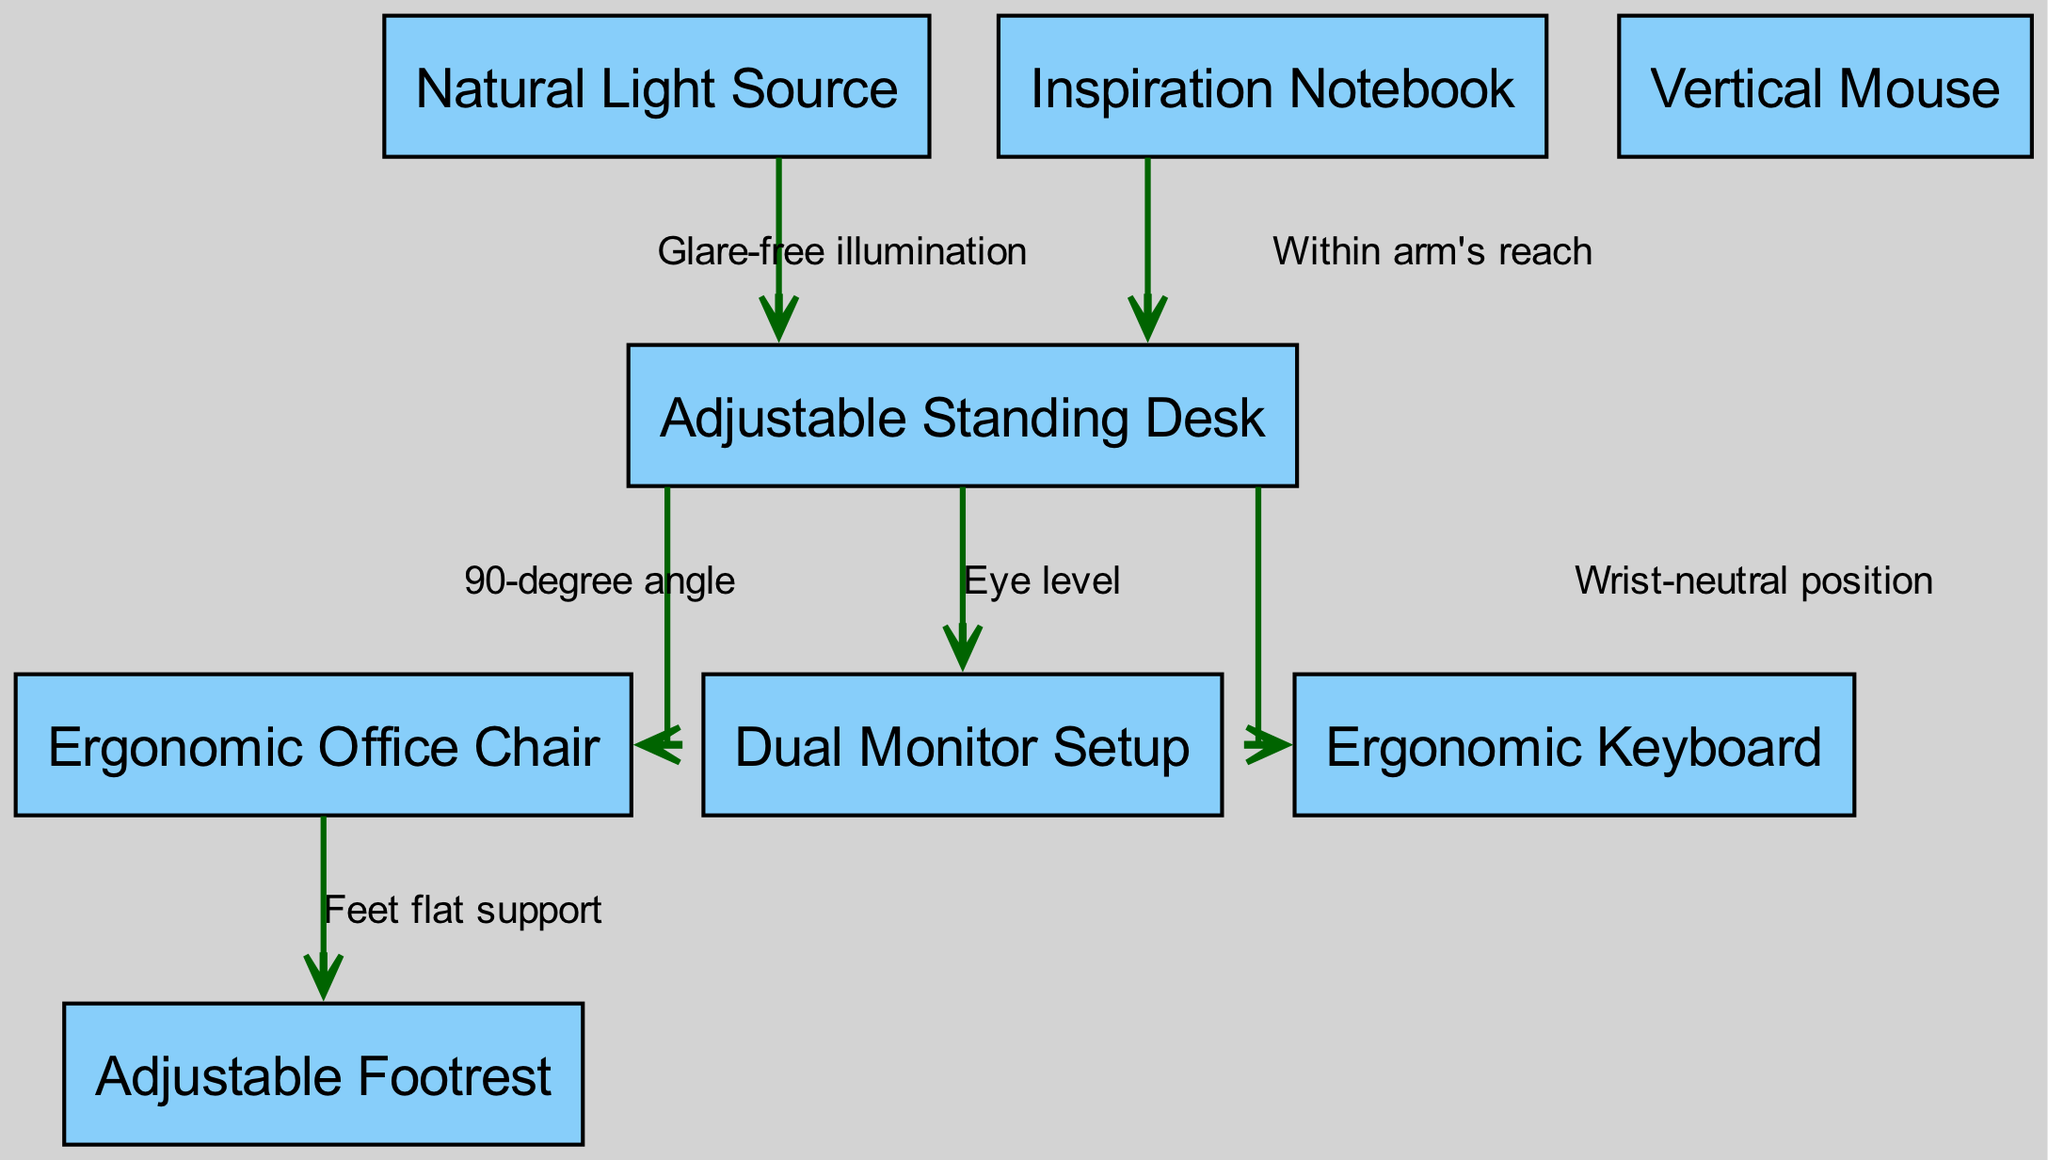What is the label of the first node? The first node in the diagram is labeled "Adjustable Standing Desk." This can be directly observed by looking at the nodes listed in the diagram.
Answer: Adjustable Standing Desk How many nodes are there in total? The diagram lists eight different components that make up the ergonomic workspace, which are labeled as nodes. Counting these nodes gives a total of eight.
Answer: Eight What is the relationship between the desk and the monitor? The diagram indicates that the desk is positioned in a way that keeps the monitor at eye level. This is specified in the edge connecting these two nodes.
Answer: Eye level What supports the feet in the chair setup? The edge connecting the chair and the footrest indicates that the footrest provides flat support for the feet while seated in the chair.
Answer: Feet flat support How does the desk relate to lighting? According to the edge labeled in the diagram, the desk is associated with a natural light source, which emphasizes the need for glare-free illumination while working.
Answer: Glare-free illumination What is the intended position for the keyboard? The diagram specifies that the relationship between the desk and the keyboard aims for a wrist-neutral position, which is crucial for ergonomic typing.
Answer: Wrist-neutral position What is the significance of the notebook’s position? The diagram indicates that the inspiration notebook should be within arm's reach of the desk, making it easily accessible for writing and inspiration. This relationship highlights a practical aspect of workspace ergonomics.
Answer: Within arm's reach What type of mouse is included in the setup? The diagram features a vertical mouse, which is important for reducing wrist strain during extended use, as indicated by the node labeling.
Answer: Vertical Mouse Which component provides a source of light? The diagram clearly indicates a "Natural Light Source" as a component that illuminates the workspace, signifying its importance for visibility and ambiance.
Answer: Natural Light Source 